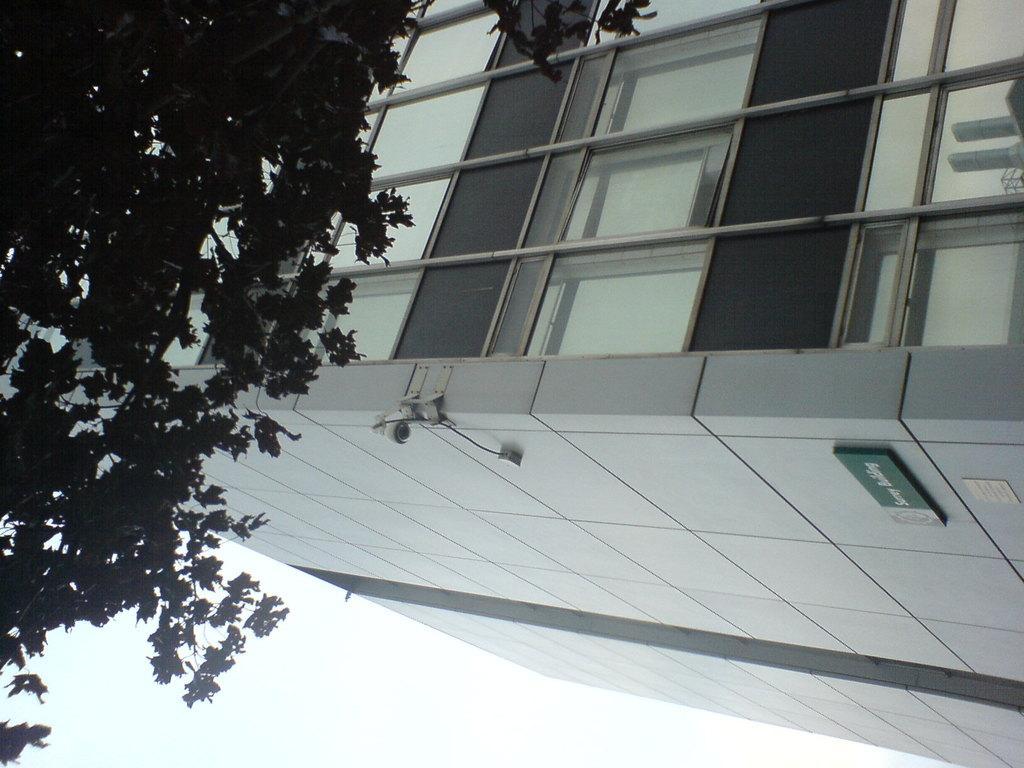Please provide a concise description of this image. Here we can see a building, board, and trees. This is sky. 